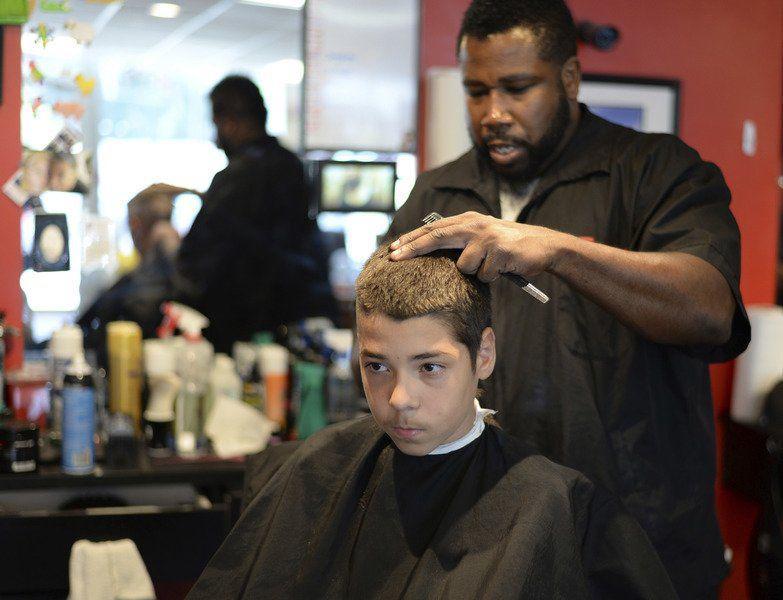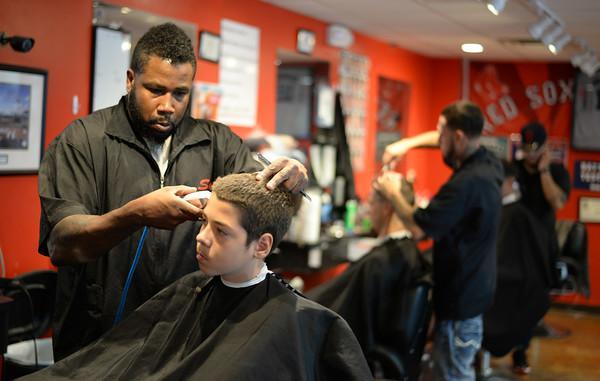The first image is the image on the left, the second image is the image on the right. Considering the images on both sides, is "At least one image shows a male barber standing to work on a customer's hair." valid? Answer yes or no. Yes. The first image is the image on the left, the second image is the image on the right. Analyze the images presented: Is the assertion "Caucasian males are getting their hair cut" valid? Answer yes or no. Yes. 